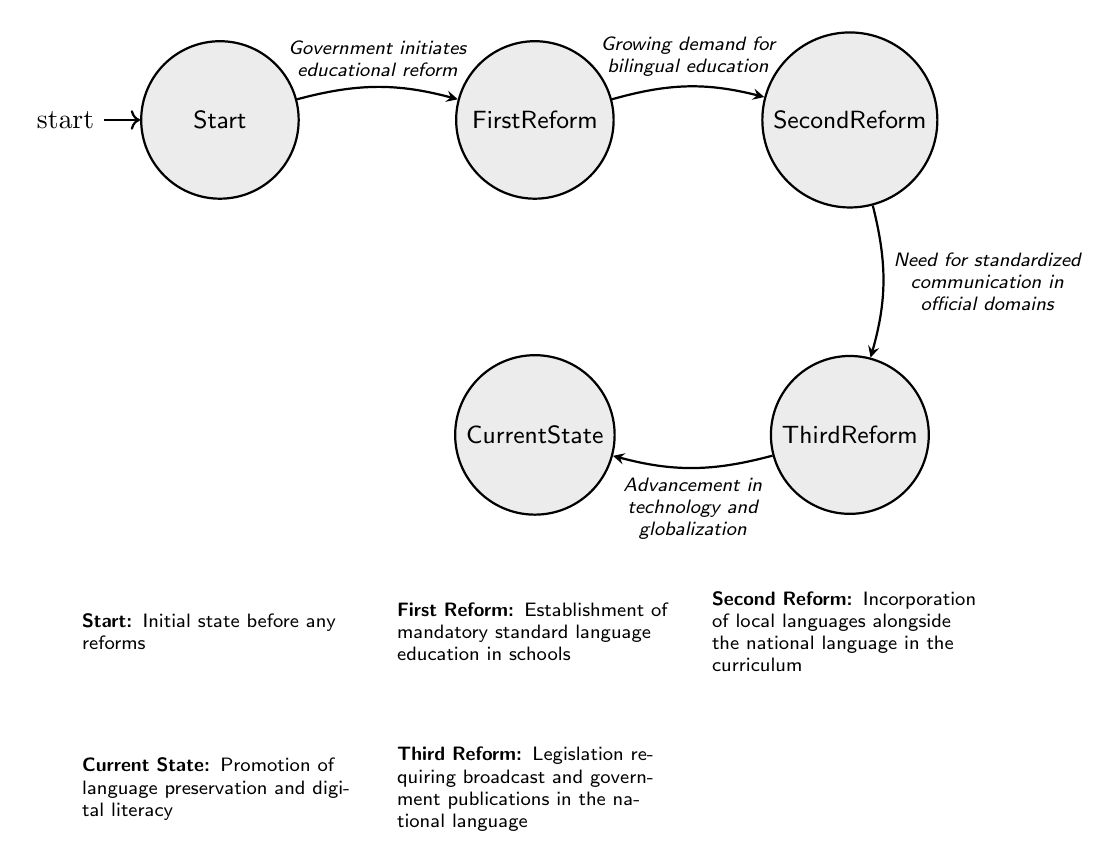What is the initial state of the language reforms? The initial state is labeled "Start," which indicates the period before any reforms were implemented.
Answer: Start What is the policy associated with the First Reform? The First Reform is associated with the establishment of mandatory standard language education in schools, as described in the diagram.
Answer: Establishment of mandatory standard language education in schools How many major language reforms are depicted in the diagram? The diagram shows four major states: Start, First Reform, Second Reform, Third Reform, and Current State. Therefore, there are four states total.
Answer: Four What triggers the transition from the Second Reform to the Third Reform? The transition from the Second Reform to the Third Reform is triggered by the need for standardized communication in official domains, as indicated in the diagram.
Answer: Need for standardized communication in official domains What policy is promoted in the Current State? The Current State promotes the preservation of language and digital literacy, as stated in the diagram.
Answer: Promotion of language preservation and digital literacy Which reform comes immediately after the First Reform? The Second Reform comes immediately after the First Reform, as depicted by the transition directed from the First Reform to the Second Reform.
Answer: Second Reform What is the relationship between the Third Reform and Current State? The Current State transitions from the Third Reform, which is a progression towards contemporary language policies.
Answer: Current State What was the primary reason for initiating the First Reform? The First Reform was initiated due to the government's decision to implement educational reform, as shown in the transition from Start to First Reform.
Answer: Government initiates educational reform What was a key factor that led to the Second Reform? The key factor that led to the Second Reform was the growing demand for bilingual education, which is indicated in the transition from First Reform to Second Reform.
Answer: Growing demand for bilingual education 